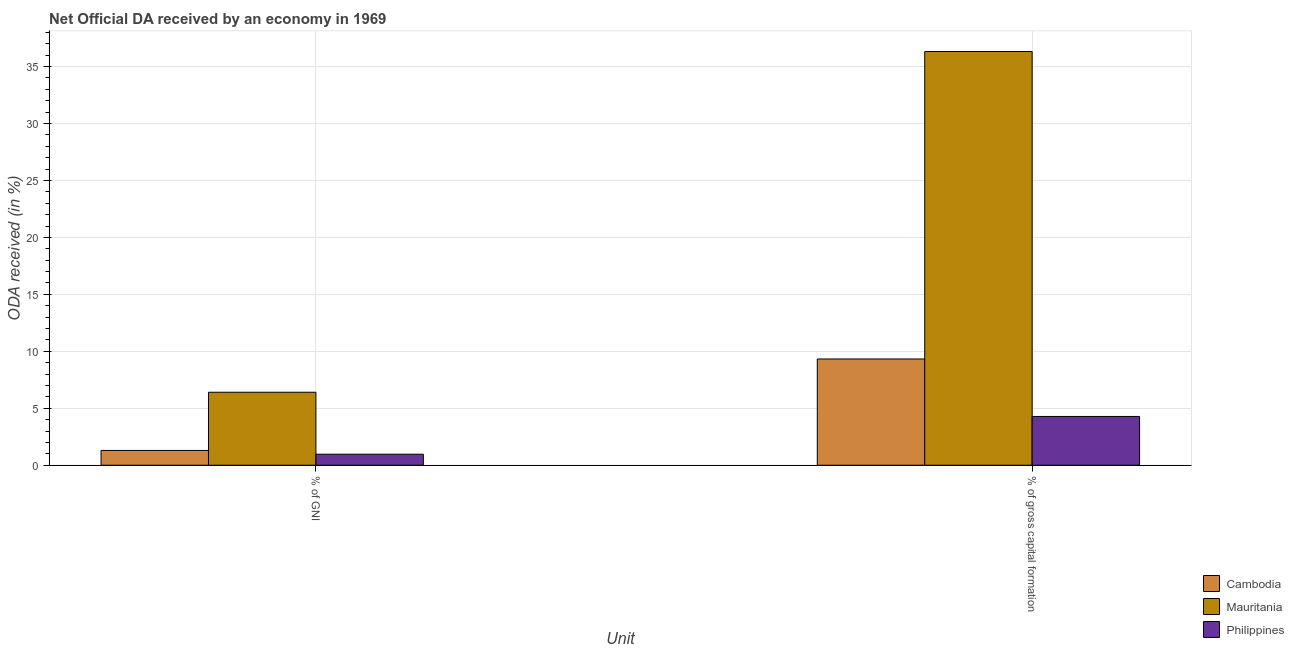How many different coloured bars are there?
Offer a terse response. 3. Are the number of bars on each tick of the X-axis equal?
Provide a succinct answer. Yes. How many bars are there on the 2nd tick from the right?
Give a very brief answer. 3. What is the label of the 1st group of bars from the left?
Your answer should be compact. % of GNI. What is the oda received as percentage of gross capital formation in Mauritania?
Offer a terse response. 36.32. Across all countries, what is the maximum oda received as percentage of gni?
Give a very brief answer. 6.41. Across all countries, what is the minimum oda received as percentage of gni?
Give a very brief answer. 0.97. In which country was the oda received as percentage of gross capital formation maximum?
Offer a very short reply. Mauritania. In which country was the oda received as percentage of gross capital formation minimum?
Your answer should be compact. Philippines. What is the total oda received as percentage of gni in the graph?
Provide a short and direct response. 8.68. What is the difference between the oda received as percentage of gross capital formation in Cambodia and that in Mauritania?
Offer a very short reply. -26.99. What is the difference between the oda received as percentage of gni in Cambodia and the oda received as percentage of gross capital formation in Mauritania?
Make the answer very short. -35.02. What is the average oda received as percentage of gross capital formation per country?
Provide a succinct answer. 16.64. What is the difference between the oda received as percentage of gross capital formation and oda received as percentage of gni in Mauritania?
Make the answer very short. 29.91. In how many countries, is the oda received as percentage of gni greater than 21 %?
Ensure brevity in your answer.  0. What is the ratio of the oda received as percentage of gni in Cambodia to that in Mauritania?
Your answer should be very brief. 0.2. Is the oda received as percentage of gni in Philippines less than that in Cambodia?
Make the answer very short. Yes. In how many countries, is the oda received as percentage of gross capital formation greater than the average oda received as percentage of gross capital formation taken over all countries?
Offer a very short reply. 1. What does the 3rd bar from the left in % of GNI represents?
Offer a very short reply. Philippines. What does the 2nd bar from the right in % of gross capital formation represents?
Provide a succinct answer. Mauritania. How many bars are there?
Provide a short and direct response. 6. What is the difference between two consecutive major ticks on the Y-axis?
Offer a terse response. 5. Are the values on the major ticks of Y-axis written in scientific E-notation?
Keep it short and to the point. No. Does the graph contain grids?
Your answer should be very brief. Yes. Where does the legend appear in the graph?
Your answer should be compact. Bottom right. How many legend labels are there?
Your answer should be very brief. 3. How are the legend labels stacked?
Your response must be concise. Vertical. What is the title of the graph?
Offer a very short reply. Net Official DA received by an economy in 1969. What is the label or title of the X-axis?
Offer a very short reply. Unit. What is the label or title of the Y-axis?
Your answer should be very brief. ODA received (in %). What is the ODA received (in %) in Cambodia in % of GNI?
Make the answer very short. 1.3. What is the ODA received (in %) in Mauritania in % of GNI?
Ensure brevity in your answer.  6.41. What is the ODA received (in %) of Philippines in % of GNI?
Your response must be concise. 0.97. What is the ODA received (in %) of Cambodia in % of gross capital formation?
Keep it short and to the point. 9.33. What is the ODA received (in %) in Mauritania in % of gross capital formation?
Provide a short and direct response. 36.32. What is the ODA received (in %) in Philippines in % of gross capital formation?
Keep it short and to the point. 4.28. Across all Unit, what is the maximum ODA received (in %) in Cambodia?
Ensure brevity in your answer.  9.33. Across all Unit, what is the maximum ODA received (in %) in Mauritania?
Offer a very short reply. 36.32. Across all Unit, what is the maximum ODA received (in %) in Philippines?
Offer a terse response. 4.28. Across all Unit, what is the minimum ODA received (in %) of Cambodia?
Make the answer very short. 1.3. Across all Unit, what is the minimum ODA received (in %) in Mauritania?
Offer a terse response. 6.41. Across all Unit, what is the minimum ODA received (in %) of Philippines?
Your answer should be very brief. 0.97. What is the total ODA received (in %) of Cambodia in the graph?
Keep it short and to the point. 10.63. What is the total ODA received (in %) of Mauritania in the graph?
Offer a terse response. 42.73. What is the total ODA received (in %) of Philippines in the graph?
Provide a short and direct response. 5.25. What is the difference between the ODA received (in %) in Cambodia in % of GNI and that in % of gross capital formation?
Ensure brevity in your answer.  -8.03. What is the difference between the ODA received (in %) in Mauritania in % of GNI and that in % of gross capital formation?
Your response must be concise. -29.91. What is the difference between the ODA received (in %) in Philippines in % of GNI and that in % of gross capital formation?
Your answer should be very brief. -3.32. What is the difference between the ODA received (in %) in Cambodia in % of GNI and the ODA received (in %) in Mauritania in % of gross capital formation?
Offer a terse response. -35.02. What is the difference between the ODA received (in %) of Cambodia in % of GNI and the ODA received (in %) of Philippines in % of gross capital formation?
Provide a succinct answer. -2.98. What is the difference between the ODA received (in %) of Mauritania in % of GNI and the ODA received (in %) of Philippines in % of gross capital formation?
Your answer should be compact. 2.13. What is the average ODA received (in %) in Cambodia per Unit?
Offer a very short reply. 5.31. What is the average ODA received (in %) of Mauritania per Unit?
Give a very brief answer. 21.36. What is the average ODA received (in %) of Philippines per Unit?
Your answer should be compact. 2.63. What is the difference between the ODA received (in %) in Cambodia and ODA received (in %) in Mauritania in % of GNI?
Provide a short and direct response. -5.11. What is the difference between the ODA received (in %) of Cambodia and ODA received (in %) of Philippines in % of GNI?
Make the answer very short. 0.33. What is the difference between the ODA received (in %) in Mauritania and ODA received (in %) in Philippines in % of GNI?
Your answer should be compact. 5.44. What is the difference between the ODA received (in %) of Cambodia and ODA received (in %) of Mauritania in % of gross capital formation?
Provide a short and direct response. -26.99. What is the difference between the ODA received (in %) of Cambodia and ODA received (in %) of Philippines in % of gross capital formation?
Your answer should be very brief. 5.05. What is the difference between the ODA received (in %) of Mauritania and ODA received (in %) of Philippines in % of gross capital formation?
Your answer should be very brief. 32.04. What is the ratio of the ODA received (in %) in Cambodia in % of GNI to that in % of gross capital formation?
Provide a short and direct response. 0.14. What is the ratio of the ODA received (in %) in Mauritania in % of GNI to that in % of gross capital formation?
Offer a terse response. 0.18. What is the ratio of the ODA received (in %) in Philippines in % of GNI to that in % of gross capital formation?
Offer a very short reply. 0.23. What is the difference between the highest and the second highest ODA received (in %) of Cambodia?
Give a very brief answer. 8.03. What is the difference between the highest and the second highest ODA received (in %) in Mauritania?
Offer a terse response. 29.91. What is the difference between the highest and the second highest ODA received (in %) of Philippines?
Give a very brief answer. 3.32. What is the difference between the highest and the lowest ODA received (in %) of Cambodia?
Make the answer very short. 8.03. What is the difference between the highest and the lowest ODA received (in %) of Mauritania?
Offer a very short reply. 29.91. What is the difference between the highest and the lowest ODA received (in %) in Philippines?
Provide a short and direct response. 3.32. 